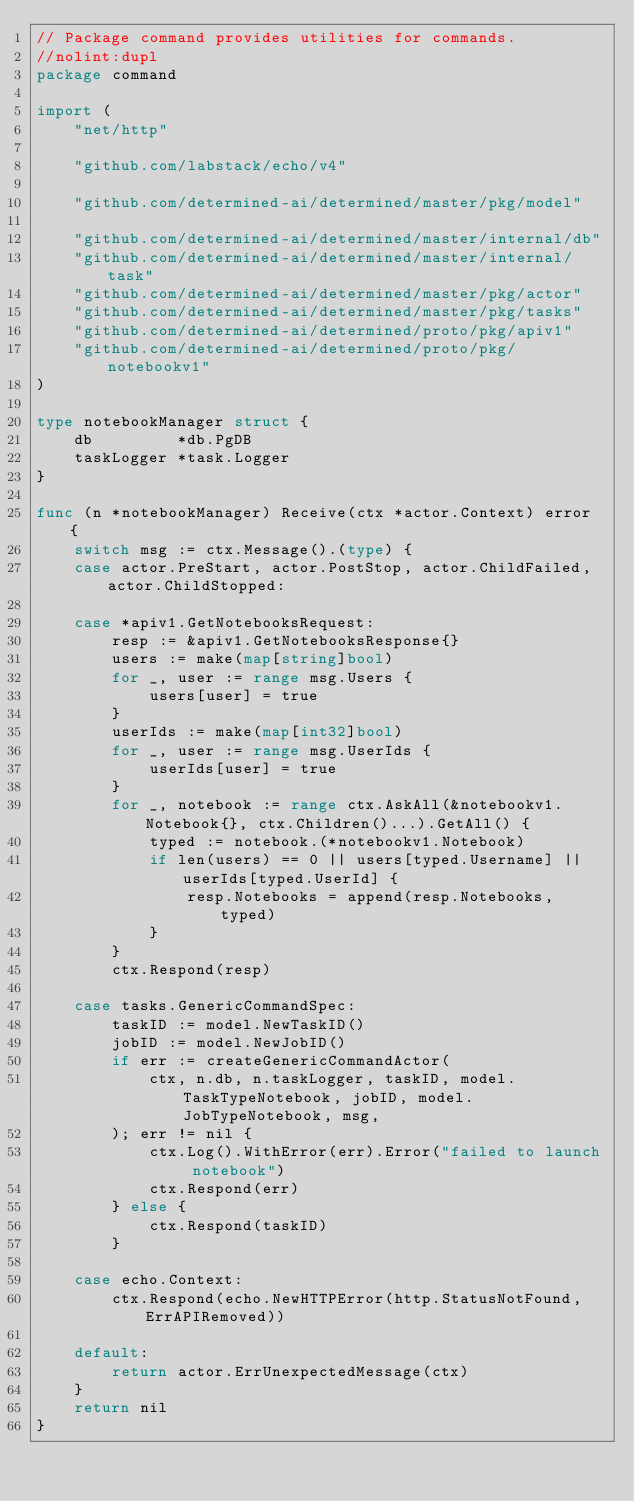<code> <loc_0><loc_0><loc_500><loc_500><_Go_>// Package command provides utilities for commands.
//nolint:dupl
package command

import (
	"net/http"

	"github.com/labstack/echo/v4"

	"github.com/determined-ai/determined/master/pkg/model"

	"github.com/determined-ai/determined/master/internal/db"
	"github.com/determined-ai/determined/master/internal/task"
	"github.com/determined-ai/determined/master/pkg/actor"
	"github.com/determined-ai/determined/master/pkg/tasks"
	"github.com/determined-ai/determined/proto/pkg/apiv1"
	"github.com/determined-ai/determined/proto/pkg/notebookv1"
)

type notebookManager struct {
	db         *db.PgDB
	taskLogger *task.Logger
}

func (n *notebookManager) Receive(ctx *actor.Context) error {
	switch msg := ctx.Message().(type) {
	case actor.PreStart, actor.PostStop, actor.ChildFailed, actor.ChildStopped:

	case *apiv1.GetNotebooksRequest:
		resp := &apiv1.GetNotebooksResponse{}
		users := make(map[string]bool)
		for _, user := range msg.Users {
			users[user] = true
		}
		userIds := make(map[int32]bool)
		for _, user := range msg.UserIds {
			userIds[user] = true
		}
		for _, notebook := range ctx.AskAll(&notebookv1.Notebook{}, ctx.Children()...).GetAll() {
			typed := notebook.(*notebookv1.Notebook)
			if len(users) == 0 || users[typed.Username] || userIds[typed.UserId] {
				resp.Notebooks = append(resp.Notebooks, typed)
			}
		}
		ctx.Respond(resp)

	case tasks.GenericCommandSpec:
		taskID := model.NewTaskID()
		jobID := model.NewJobID()
		if err := createGenericCommandActor(
			ctx, n.db, n.taskLogger, taskID, model.TaskTypeNotebook, jobID, model.JobTypeNotebook, msg,
		); err != nil {
			ctx.Log().WithError(err).Error("failed to launch notebook")
			ctx.Respond(err)
		} else {
			ctx.Respond(taskID)
		}

	case echo.Context:
		ctx.Respond(echo.NewHTTPError(http.StatusNotFound, ErrAPIRemoved))

	default:
		return actor.ErrUnexpectedMessage(ctx)
	}
	return nil
}
</code> 